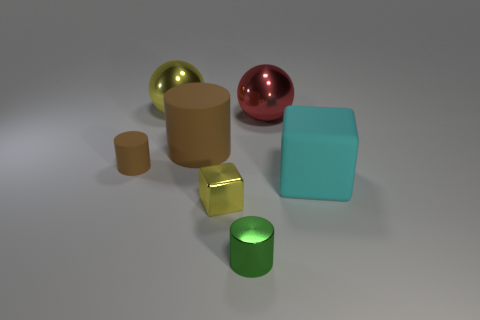Subtract all metal cylinders. How many cylinders are left? 2 Add 3 green cylinders. How many objects exist? 10 Subtract all green cylinders. How many cylinders are left? 2 Subtract 1 spheres. How many spheres are left? 1 Add 6 large gray matte things. How many large gray matte things exist? 6 Subtract 0 gray blocks. How many objects are left? 7 Subtract all blocks. How many objects are left? 5 Subtract all purple blocks. Subtract all green spheres. How many blocks are left? 2 Subtract all green cubes. How many yellow spheres are left? 1 Subtract all tiny gray rubber cylinders. Subtract all tiny yellow metal objects. How many objects are left? 6 